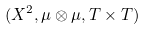<formula> <loc_0><loc_0><loc_500><loc_500>( X ^ { 2 } , \mu \otimes \mu , T \times T )</formula> 